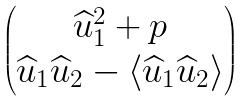<formula> <loc_0><loc_0><loc_500><loc_500>\begin{pmatrix} \widehat { u } _ { 1 } ^ { 2 } + p \\ \widehat { u } _ { 1 } \widehat { u } _ { 2 } - \langle \widehat { u } _ { 1 } \widehat { u } _ { 2 } \rangle \end{pmatrix}</formula> 